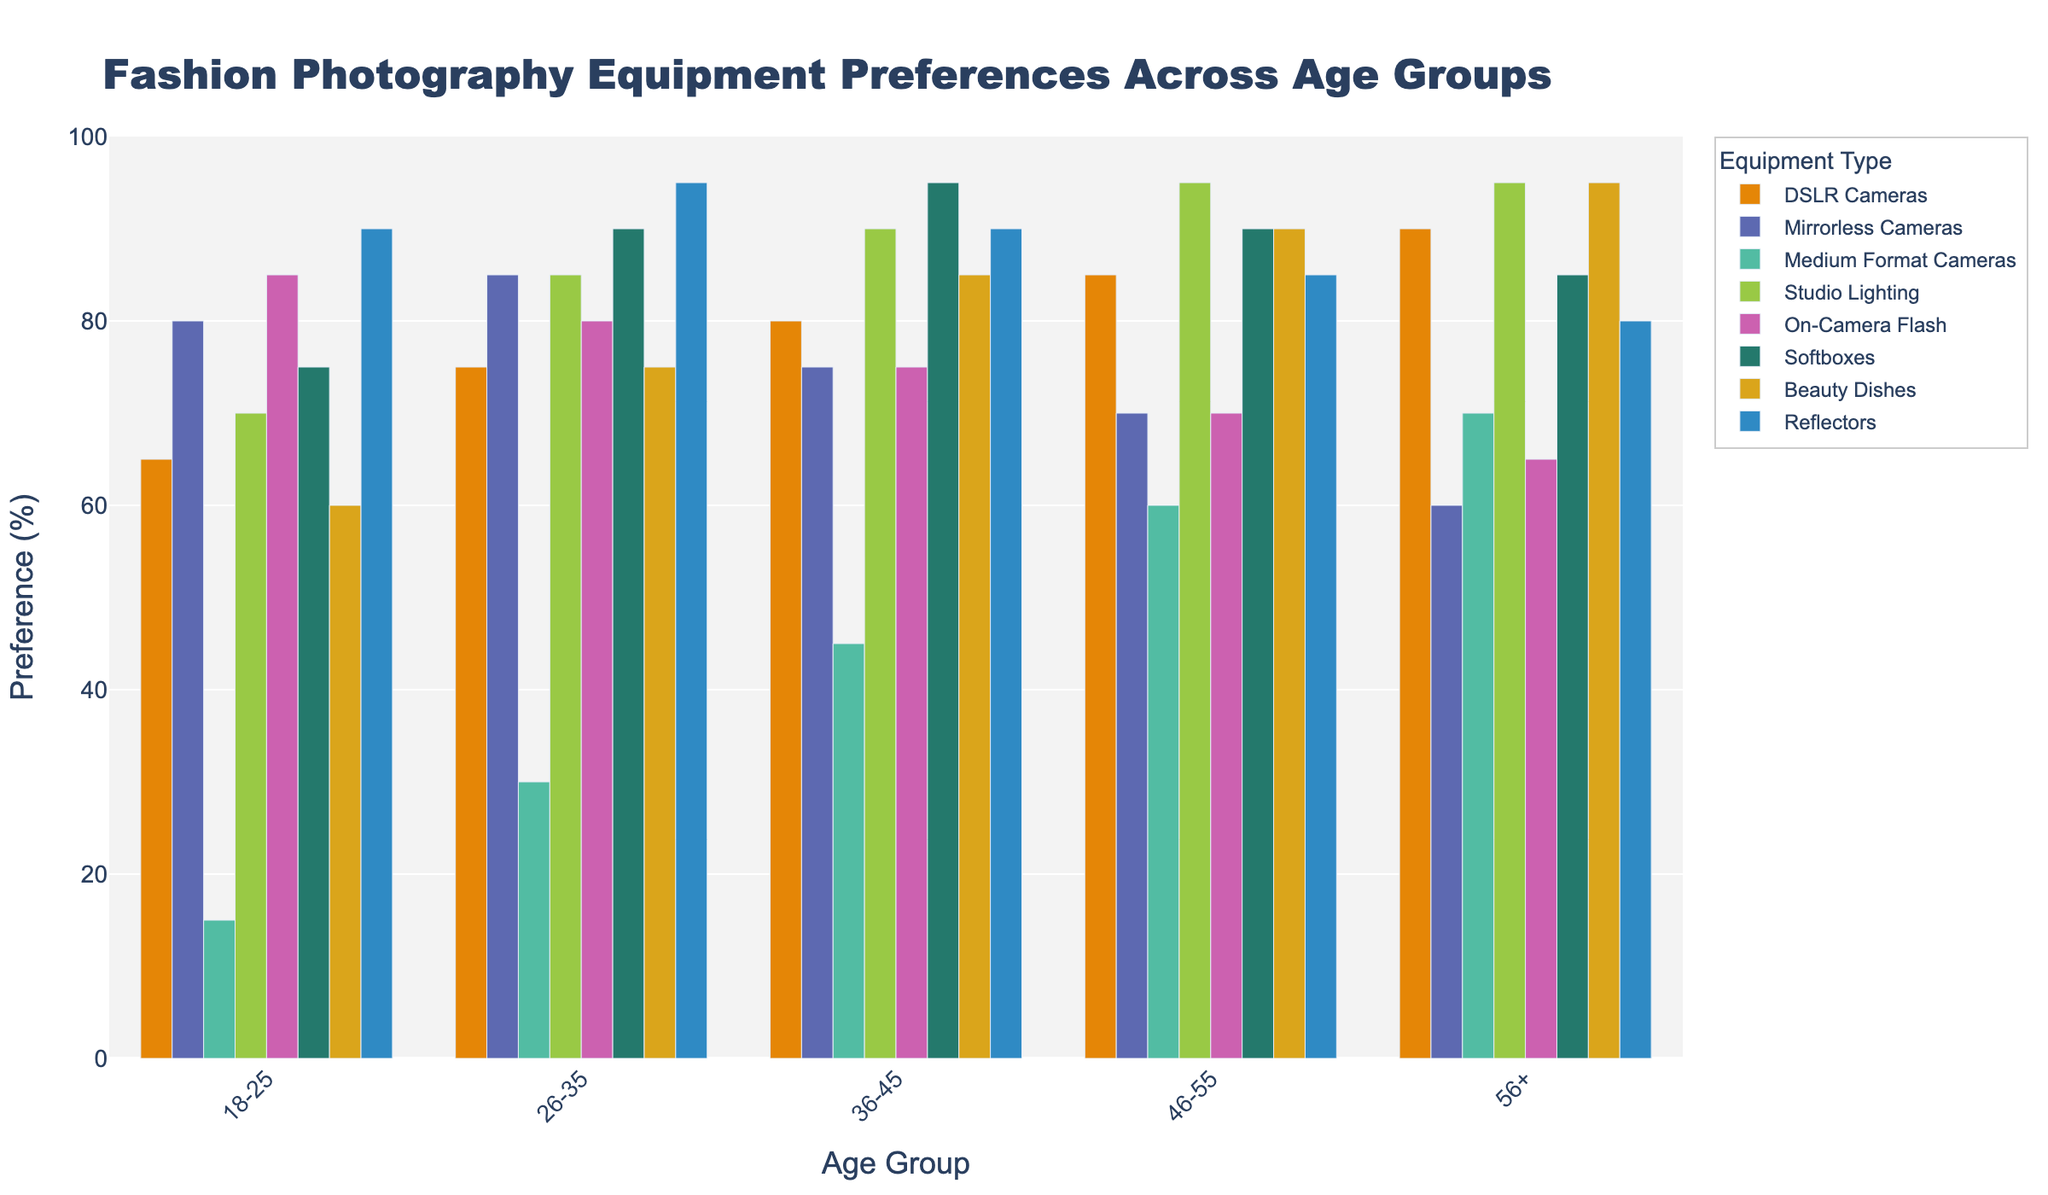Which age group has the highest preference for Medium Format Cameras? Look at the bars representing Medium Format Cameras across all age groups. The 56+ group has the tallest bar. Therefore, this group has the highest preference for Medium Format Cameras.
Answer: 56+ Which equipment type is most preferred by the 18-25 age group? Observe the bars for the 18-25 age group. The On-Camera Flash bar is the tallest for this group.
Answer: On-Camera Flash Between Softboxes and Beauty Dishes, which one is more preferred by the 26-35 age group? Compare the heights of the bars for Softboxes and Beauty Dishes within the 26-35 group. The Softboxes bar is taller.
Answer: Softboxes What is the average preference for Studio Lighting across all age groups? Add the preferences for Studio Lighting across all age groups: (70 + 85 + 90 + 95 + 95) = 435. Then, divide by the number of age groups. 435 / 5 = 87
Answer: 87 Which age group has the least preference for Mirrorless Cameras? Look at the bars representing Mirrorless Cameras. The 56+ age group has the shortest bar.
Answer: 56+ Is the preference for DSLR Cameras generally increasing or decreasing with age? Observe the heights of the DSLR Cameras bars across age groups. The heights increase from 18-25 to 56+.
Answer: Increasing What are the total preferences for Beauty Dishes across all age groups? Add the preferences for Beauty Dishes across all age groups: (60 + 75 + 85 + 90 + 95) = 405
Answer: 405 For the 36-45 age group, which equipment types have the same preference value? In the 36-45 age group, Studio Lighting and Reflectors both have bars with heights of 90.
Answer: Studio Lighting and Reflectors How does the preference for On-Camera Flash compare between the 18-25 and 56+ age groups? Compare the heights of the bars for On-Camera Flash in the 18-25 and 56+ groups. The height is 85 for 18-25 and 65 for 56+, showing a decrease.
Answer: Decrease 